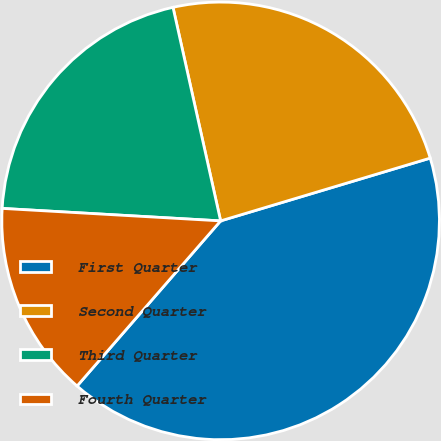Convert chart to OTSL. <chart><loc_0><loc_0><loc_500><loc_500><pie_chart><fcel>First Quarter<fcel>Second Quarter<fcel>Third Quarter<fcel>Fourth Quarter<nl><fcel>41.02%<fcel>23.86%<fcel>20.6%<fcel>14.52%<nl></chart> 